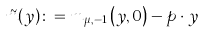<formula> <loc_0><loc_0><loc_500><loc_500>\tilde { m } ( y ) \colon = m _ { \mu , - 1 } \left ( y , 0 \right ) - p \cdot y</formula> 